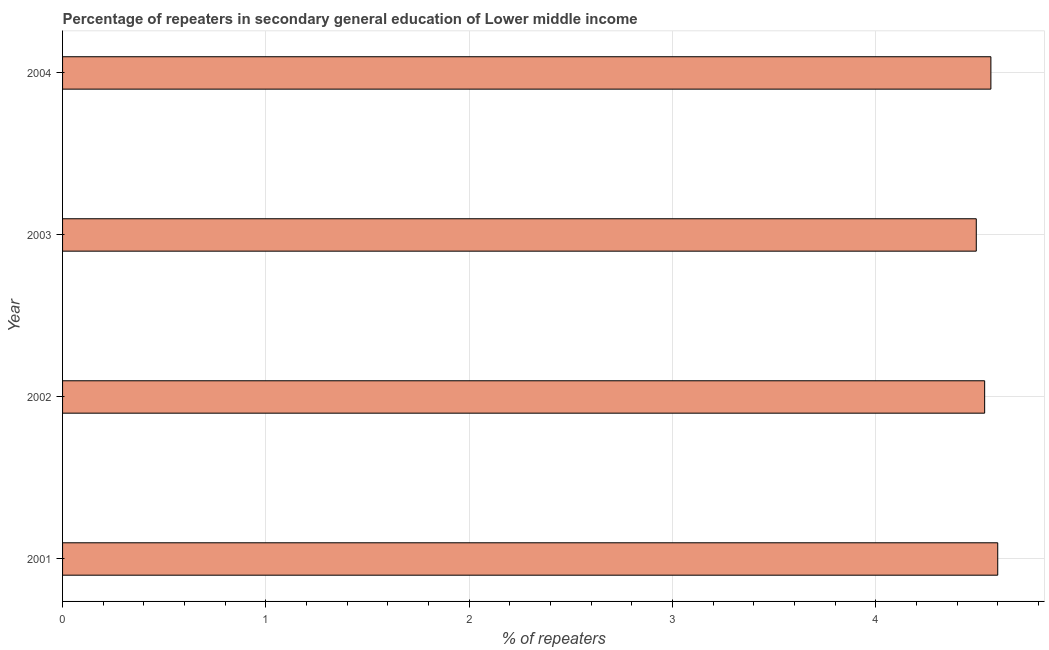What is the title of the graph?
Your answer should be very brief. Percentage of repeaters in secondary general education of Lower middle income. What is the label or title of the X-axis?
Your response must be concise. % of repeaters. What is the percentage of repeaters in 2002?
Your answer should be very brief. 4.54. Across all years, what is the maximum percentage of repeaters?
Provide a succinct answer. 4.6. Across all years, what is the minimum percentage of repeaters?
Provide a short and direct response. 4.49. What is the sum of the percentage of repeaters?
Your answer should be compact. 18.2. What is the difference between the percentage of repeaters in 2002 and 2004?
Your response must be concise. -0.03. What is the average percentage of repeaters per year?
Keep it short and to the point. 4.55. What is the median percentage of repeaters?
Offer a terse response. 4.55. In how many years, is the percentage of repeaters greater than 4 %?
Provide a succinct answer. 4. What is the ratio of the percentage of repeaters in 2001 to that in 2004?
Keep it short and to the point. 1.01. Is the difference between the percentage of repeaters in 2002 and 2003 greater than the difference between any two years?
Your response must be concise. No. What is the difference between the highest and the second highest percentage of repeaters?
Your answer should be compact. 0.03. Is the sum of the percentage of repeaters in 2002 and 2004 greater than the maximum percentage of repeaters across all years?
Provide a succinct answer. Yes. What is the difference between the highest and the lowest percentage of repeaters?
Offer a terse response. 0.11. In how many years, is the percentage of repeaters greater than the average percentage of repeaters taken over all years?
Offer a very short reply. 2. Are the values on the major ticks of X-axis written in scientific E-notation?
Your response must be concise. No. What is the % of repeaters in 2001?
Give a very brief answer. 4.6. What is the % of repeaters in 2002?
Your answer should be very brief. 4.54. What is the % of repeaters in 2003?
Offer a very short reply. 4.49. What is the % of repeaters in 2004?
Provide a succinct answer. 4.57. What is the difference between the % of repeaters in 2001 and 2002?
Provide a succinct answer. 0.06. What is the difference between the % of repeaters in 2001 and 2003?
Your response must be concise. 0.11. What is the difference between the % of repeaters in 2001 and 2004?
Ensure brevity in your answer.  0.03. What is the difference between the % of repeaters in 2002 and 2003?
Offer a very short reply. 0.04. What is the difference between the % of repeaters in 2002 and 2004?
Your response must be concise. -0.03. What is the difference between the % of repeaters in 2003 and 2004?
Provide a succinct answer. -0.07. What is the ratio of the % of repeaters in 2001 to that in 2002?
Make the answer very short. 1.01. What is the ratio of the % of repeaters in 2001 to that in 2004?
Keep it short and to the point. 1.01. What is the ratio of the % of repeaters in 2003 to that in 2004?
Make the answer very short. 0.98. 